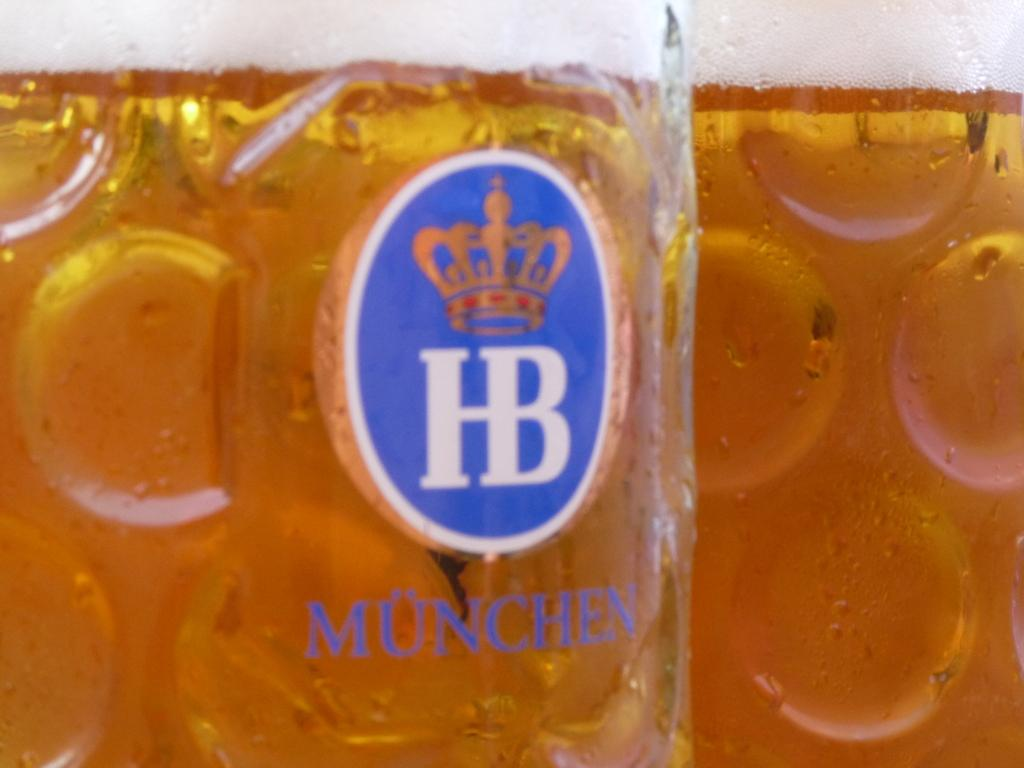<image>
Provide a brief description of the given image. A glass has the brand name Munchen on it and a crown. 